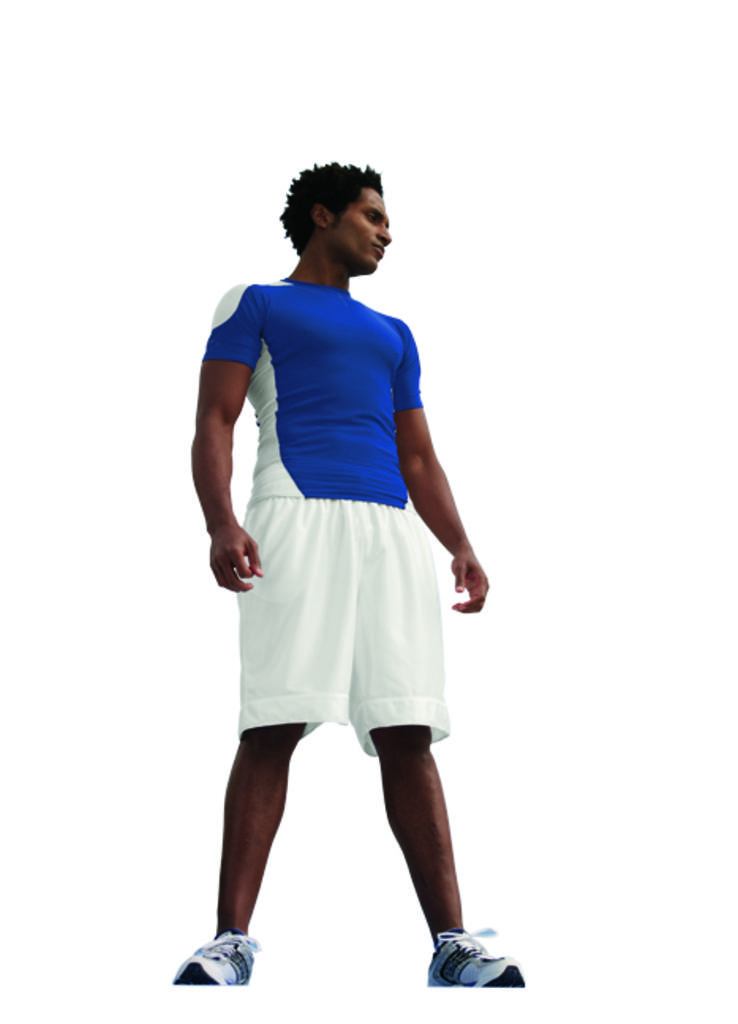What type of character is in the image? There is an animated person in the image. What color is the T-shirt worn by the animated person? The animated person is wearing a blue color T-shirt. What color are the shorts worn by the animated person? The animated person is wearing white color shorts. What color is the background of the image? The background of the image is white. What type of calendar is hanging on the wall in the image? There is no calendar present in the image; it features an animated person wearing a blue T-shirt and white shorts against a white background. 